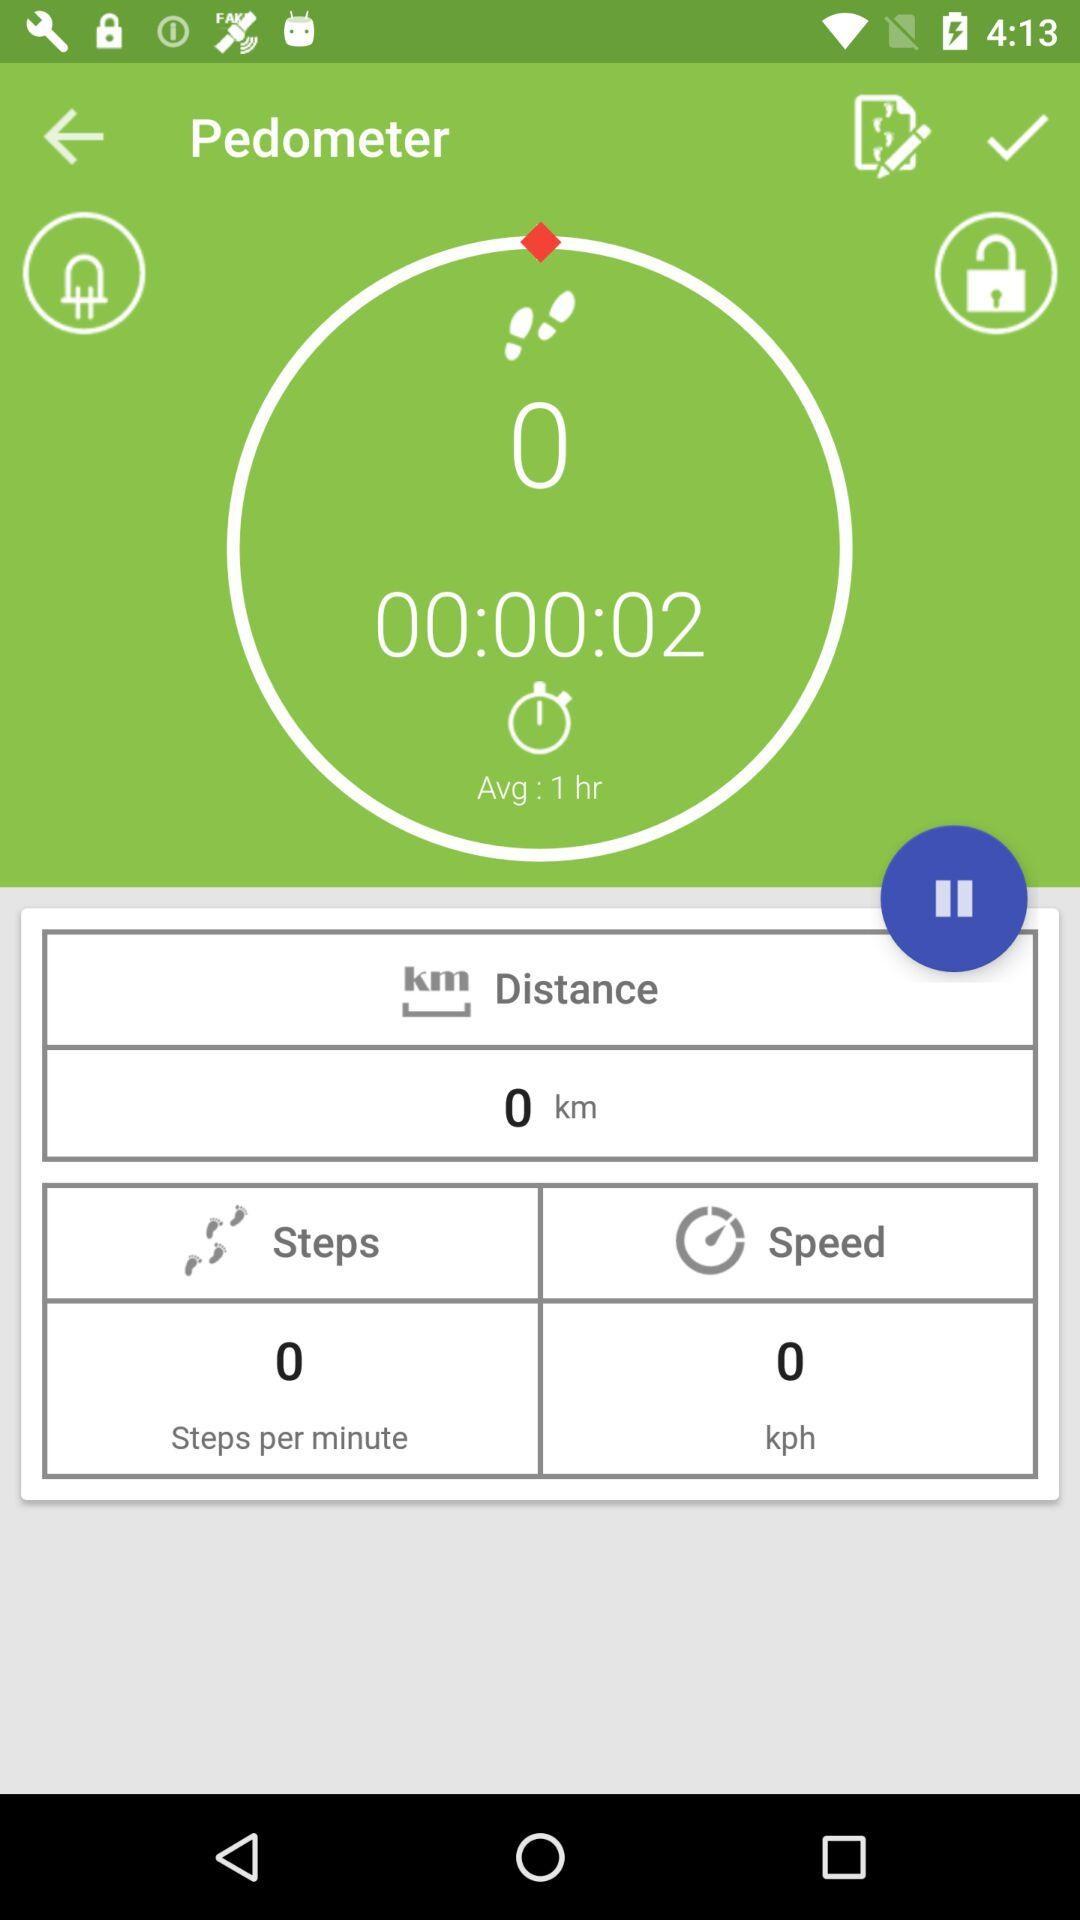How many minutes has the user been walking?
Answer the question using a single word or phrase. 00:00:02 